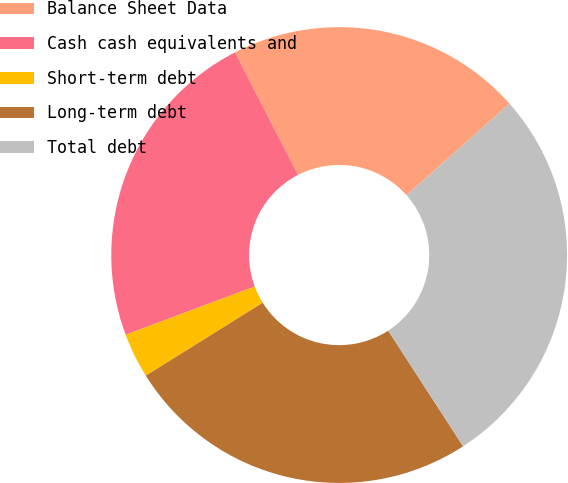Convert chart. <chart><loc_0><loc_0><loc_500><loc_500><pie_chart><fcel>Balance Sheet Data<fcel>Cash cash equivalents and<fcel>Short-term debt<fcel>Long-term debt<fcel>Total debt<nl><fcel>20.99%<fcel>23.13%<fcel>3.19%<fcel>25.27%<fcel>27.41%<nl></chart> 